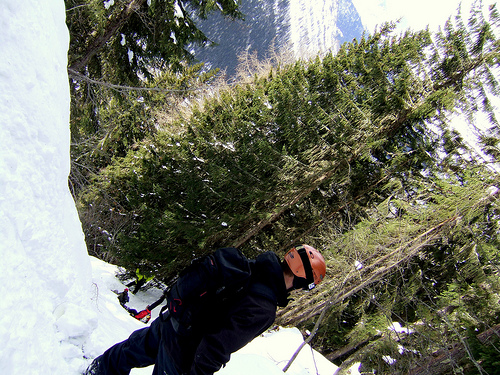<image>
Is there a helmet next to the mountain? No. The helmet is not positioned next to the mountain. They are located in different areas of the scene. 